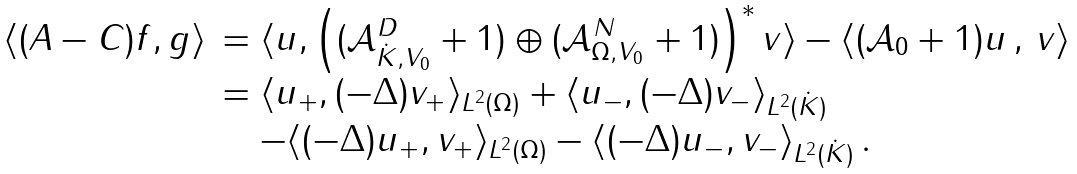<formula> <loc_0><loc_0><loc_500><loc_500>\begin{array} { l l } \langle ( A - C ) f , g \rangle & = \langle u , \left ( ( \mathcal { A } ^ { D } _ { \dot { K } , V _ { 0 } } + 1 ) \oplus ( \mathcal { A } ^ { N } _ { \Omega , V _ { 0 } } + 1 ) \right ) ^ { * } v \rangle - \langle ( \mathcal { A } _ { 0 } + 1 ) u \, , \, v \rangle \\ & = \langle u _ { + } , ( - \Delta ) v _ { + } \rangle _ { L ^ { 2 } ( \Omega ) } + \langle u _ { - } , ( - \Delta ) v _ { - } \rangle _ { L ^ { 2 } ( \dot { K } ) } \\ & \quad - \langle ( - \Delta ) u _ { + } , v _ { + } \rangle _ { L ^ { 2 } ( \Omega ) } - \langle ( - \Delta ) u _ { - } , v _ { - } \rangle _ { L ^ { 2 } ( \dot { K } ) } \, . \end{array}</formula> 